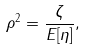Convert formula to latex. <formula><loc_0><loc_0><loc_500><loc_500>\rho ^ { 2 } = \frac { \zeta } { E [ \eta ] } ,</formula> 